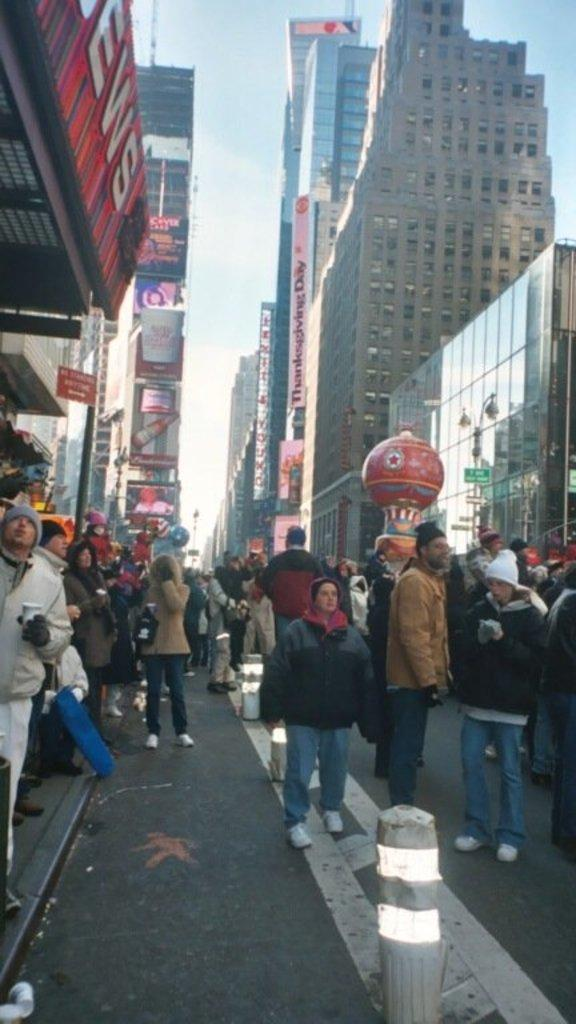What type of structures can be seen in the image? There are buildings in the image. Are there any people present in the image? Yes, there are people standing in the image. Can you describe the clothing of some people in the image? Some people are wearing caps in the image. What is a man holding in the image? A man is holding a cup in the image. How would you describe the sky in the image? The sky is blue and cloudy in the image. What color is the brain of the person standing in the image? There is no brain visible in the image; it is a picture of buildings and people. What type of engine can be seen powering the vehicle in the image? There is no vehicle or engine present in the image. 